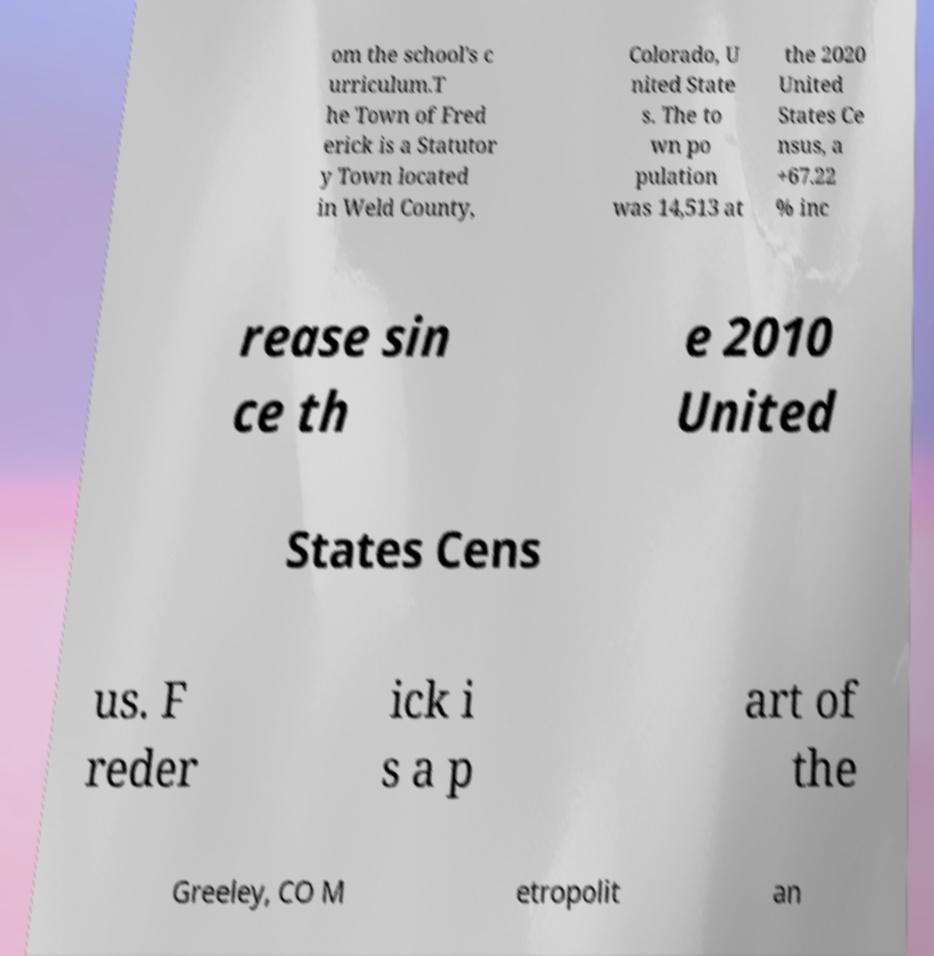There's text embedded in this image that I need extracted. Can you transcribe it verbatim? om the school's c urriculum.T he Town of Fred erick is a Statutor y Town located in Weld County, Colorado, U nited State s. The to wn po pulation was 14,513 at the 2020 United States Ce nsus, a +67.22 % inc rease sin ce th e 2010 United States Cens us. F reder ick i s a p art of the Greeley, CO M etropolit an 